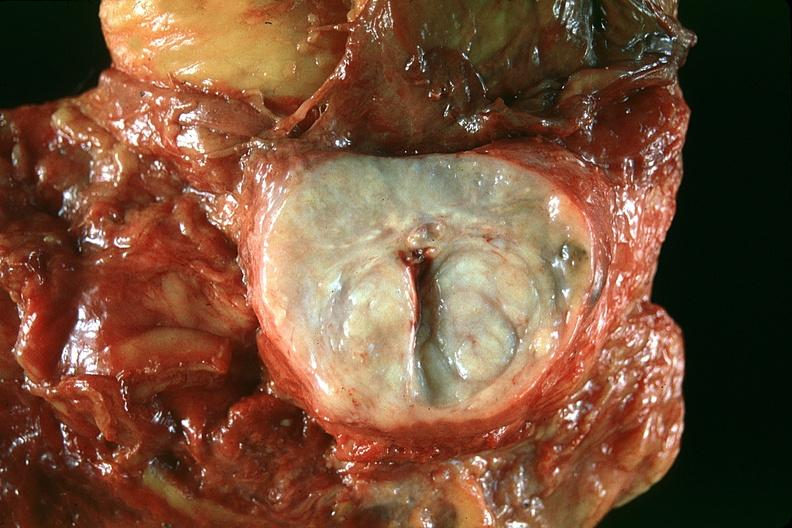where is this?
Answer the question using a single word or phrase. Urinary 